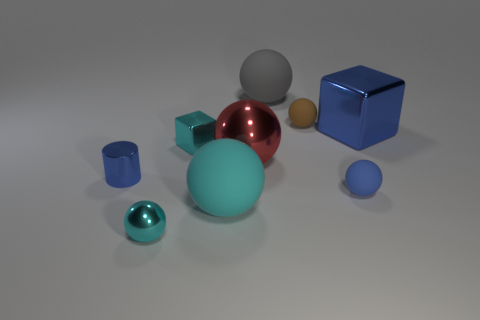Are there fewer big gray shiny blocks than big red shiny objects?
Your answer should be compact. Yes. There is a gray ball that is the same size as the cyan rubber thing; what is its material?
Ensure brevity in your answer.  Rubber. What number of things are large yellow metallic spheres or rubber balls?
Your response must be concise. 4. What number of metallic things are both on the left side of the blue block and behind the small cyan ball?
Your answer should be very brief. 3. Is the number of big metal balls that are to the right of the blue ball less than the number of large spheres?
Your response must be concise. Yes. There is a brown matte object that is the same size as the metal cylinder; what is its shape?
Provide a succinct answer. Sphere. How many other things are there of the same color as the small block?
Provide a succinct answer. 2. Is the size of the gray thing the same as the blue cylinder?
Provide a succinct answer. No. What number of objects are cyan objects or blue objects that are behind the small cube?
Offer a very short reply. 4. Is the number of tiny blue things that are left of the small blue matte object less than the number of cyan objects that are in front of the cyan metallic ball?
Make the answer very short. No. 